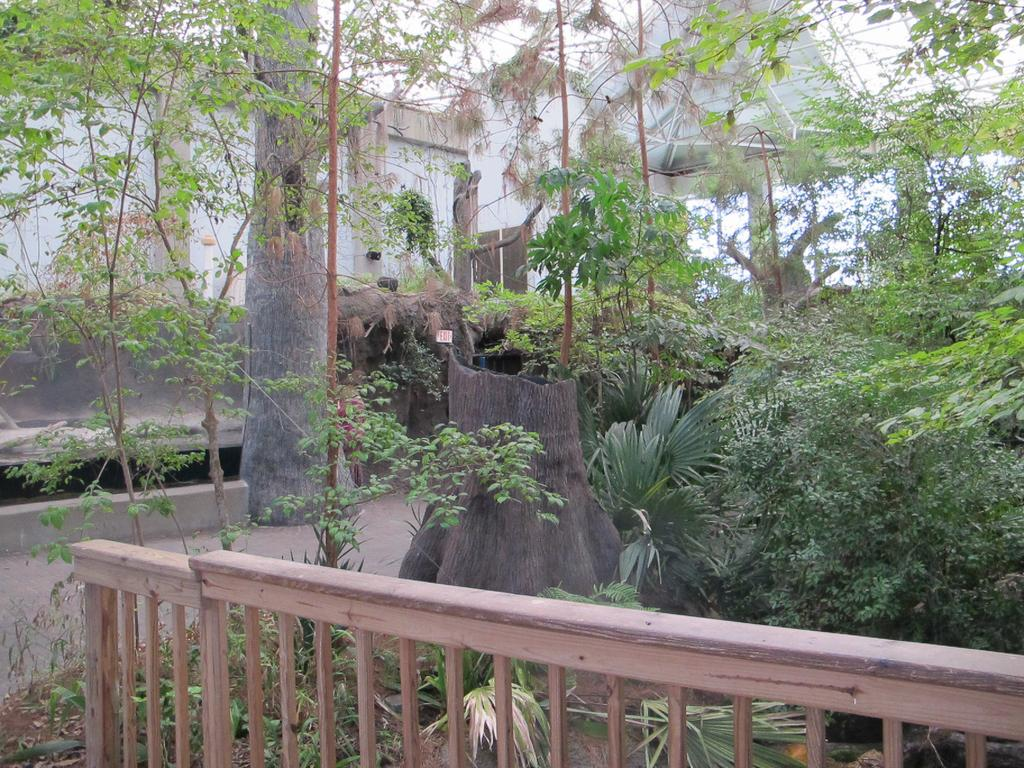What type of vegetation is present in the image? There are many trees in the image. What type of fencing can be seen at the bottom of the image? There is wooden fencing at the bottom of the image. What type of structure is visible in the background of the image? There is a building in the background of the image. What type of skin condition can be seen on the trees in the image? There is no indication of any skin condition on the trees in the image; they appear to be healthy. 